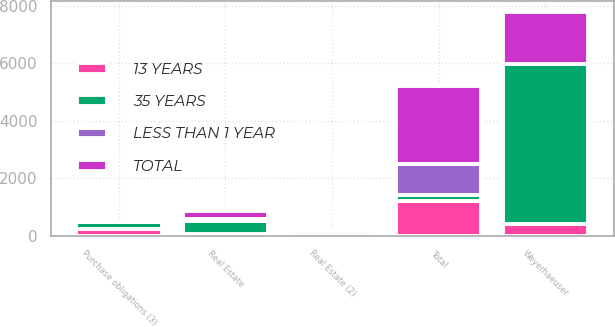<chart> <loc_0><loc_0><loc_500><loc_500><stacked_bar_chart><ecel><fcel>Weyerhaeuser<fcel>Real Estate<fcel>Real Estate (2)<fcel>Purchase obligations (3)<fcel>Total<nl><fcel>35 YEARS<fcel>5564<fcel>456<fcel>141<fcel>248<fcel>215<nl><fcel>13 YEARS<fcel>407<fcel>52<fcel>20<fcel>215<fcel>1199<nl><fcel>LESS THAN 1 YEAR<fcel>3<fcel>70<fcel>27<fcel>10<fcel>1062<nl><fcel>TOTAL<fcel>1808<fcel>272<fcel>18<fcel>7<fcel>2727<nl></chart> 